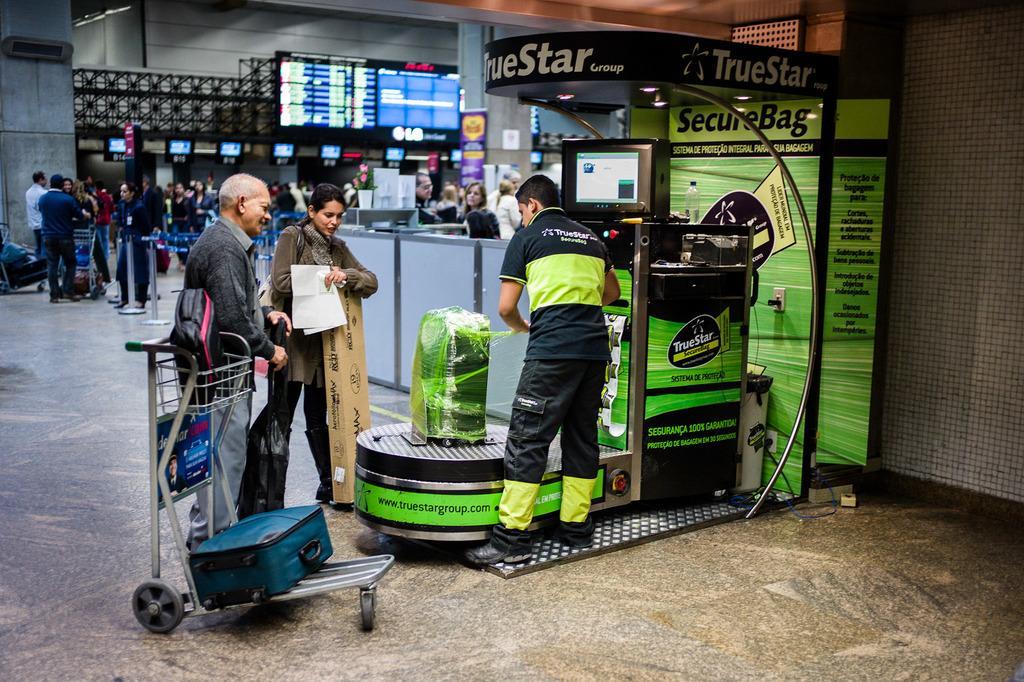In one or two sentences, can you explain what this image depicts? There is one man standing and packing a briefcase on a machine as we can see in the middle of this image. We can see the people in the background. There is a briefcase kept on a trolley is on the left side of this image. There is a screen on the right side of this image and at the top of this image as well. 